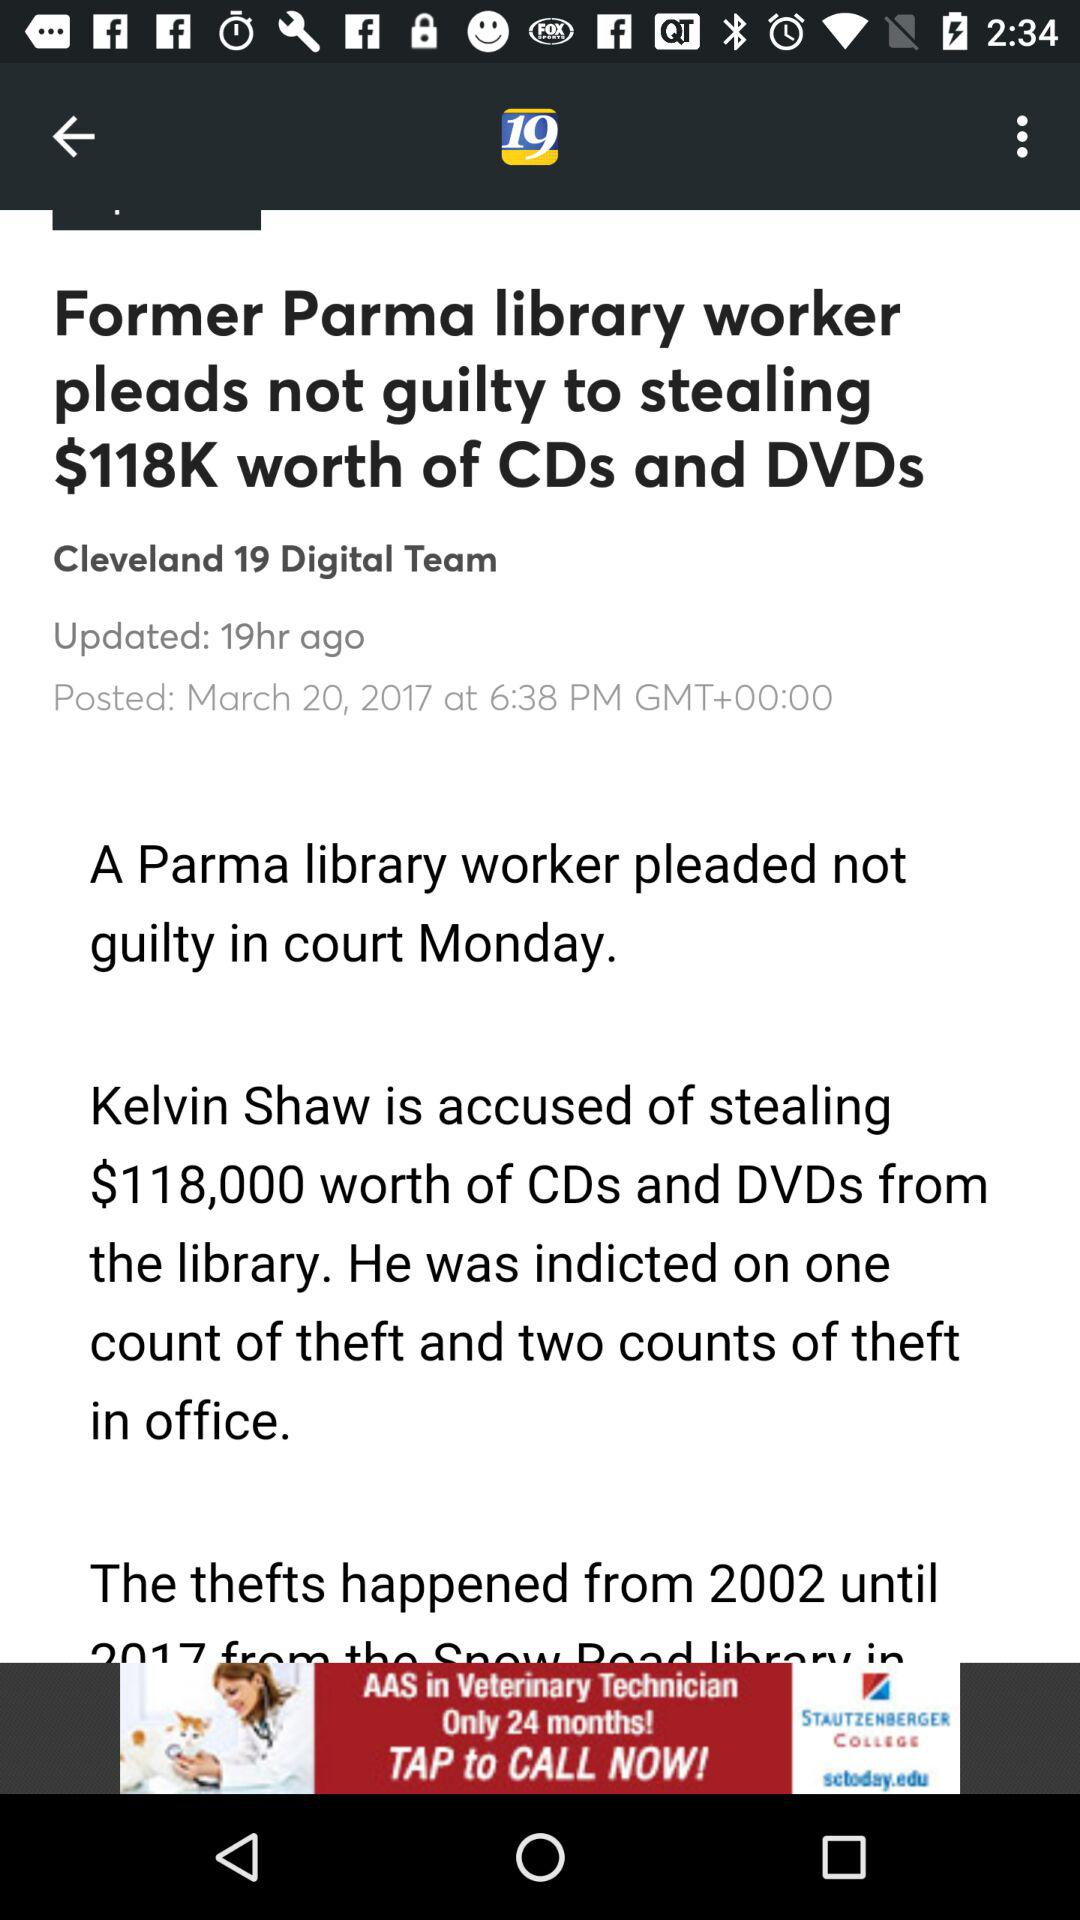How many hours ago was the article updated? The article was updated 19 hours ago. 